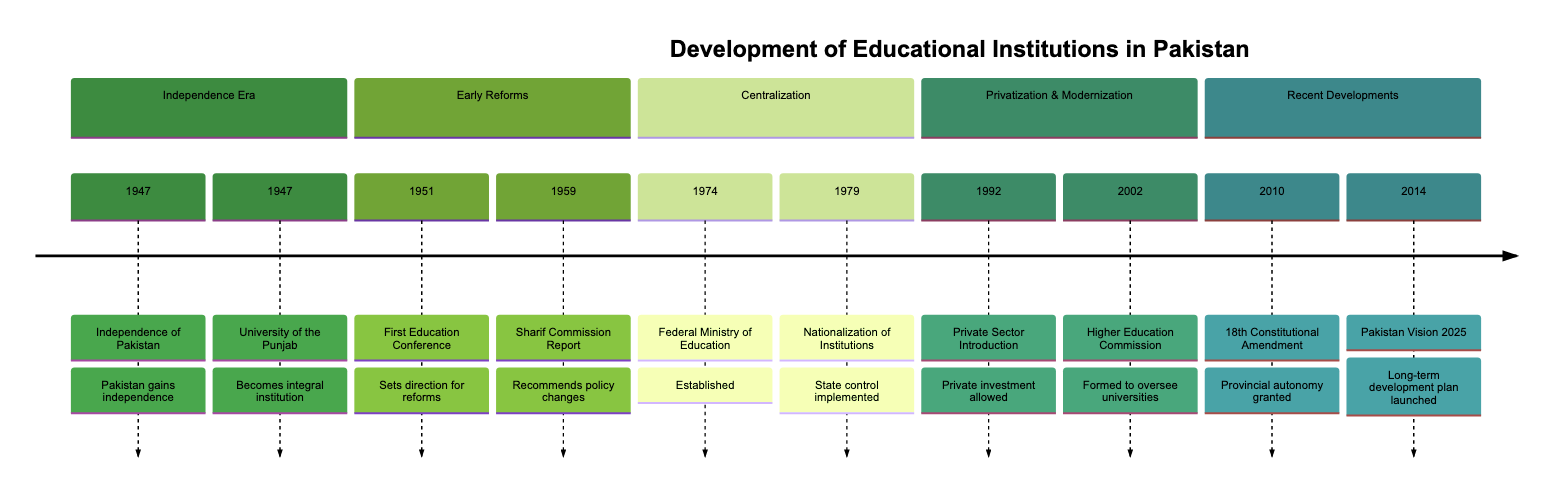What year did Pakistan gain independence? The diagram states that Pakistan gained independence in 1947. The event is listed first at the top of the timeline.
Answer: 1947 What is the first educational institution established in Pakistan? The timeline indicates that the University of the Punjab was established in 1947 and is noted as an integral institution for Pakistan.
Answer: University of the Punjab How many significant events are marked in the timeline? By counting each event listed under the different sections in the timeline, there are a total of 10 events from 1947 to 2014.
Answer: 10 What major reform occurred in 1959? The Sharif Commission Report is noted in the timeline as a significant event in 1959, which recommended changes in education policy.
Answer: Sharif Commission Report What significant change occurred in 1974 regarding educational governance? The establishment of the Federal Ministry of Education in 1974 is mentioned in the timeline as a pivotal change coordinating national educational policies.
Answer: Federal Ministry of Education Name the year when the Higher Education Commission was formed. The diagram clearly states that the Higher Education Commission was formed in 2002. This is indicated in the "Privatization & Modernization" section.
Answer: 2002 How many years passed between the establishment of the Federal Ministry of Education and the introduction of the private sector in education? The Federal Ministry of Education was established in 1974, and the introduction of the private sector in education occurred in 1992. The difference between these two years is 18 years.
Answer: 18 years What key document was launched in 2014 regarding educational development? The timeline specifies that in 2014, the government launched the Pakistan Vision 2025, focusing on improving educational quality and infrastructure.
Answer: Pakistan Vision 2025 Which event marked the transition of educational control from private to public in 1979? The nationalization of educational institutions in 1979 is indicated as the event, bringing private institutions under state control.
Answer: Nationalization of Educational Institutions 